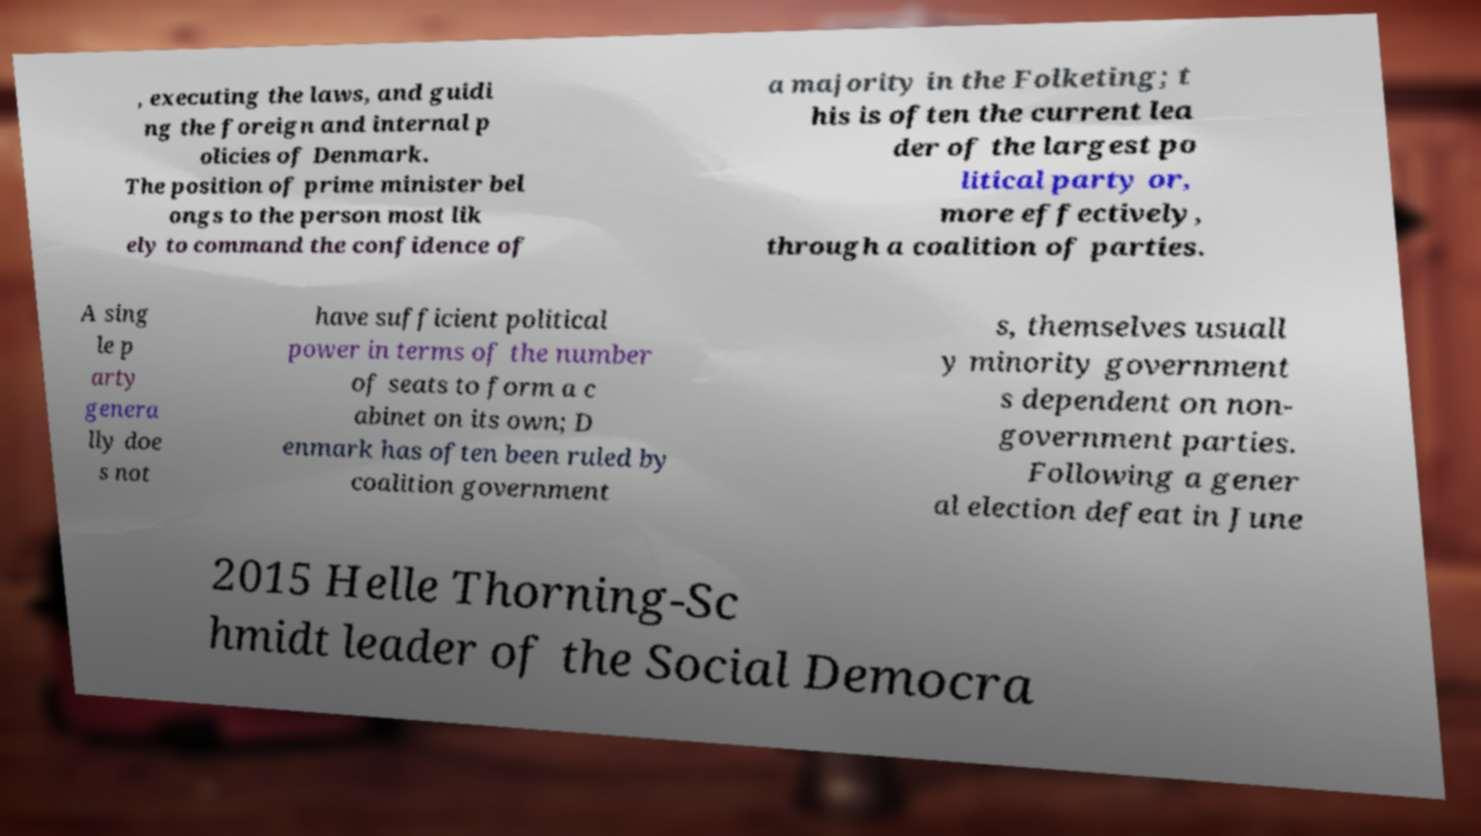What messages or text are displayed in this image? I need them in a readable, typed format. , executing the laws, and guidi ng the foreign and internal p olicies of Denmark. The position of prime minister bel ongs to the person most lik ely to command the confidence of a majority in the Folketing; t his is often the current lea der of the largest po litical party or, more effectively, through a coalition of parties. A sing le p arty genera lly doe s not have sufficient political power in terms of the number of seats to form a c abinet on its own; D enmark has often been ruled by coalition government s, themselves usuall y minority government s dependent on non- government parties. Following a gener al election defeat in June 2015 Helle Thorning-Sc hmidt leader of the Social Democra 